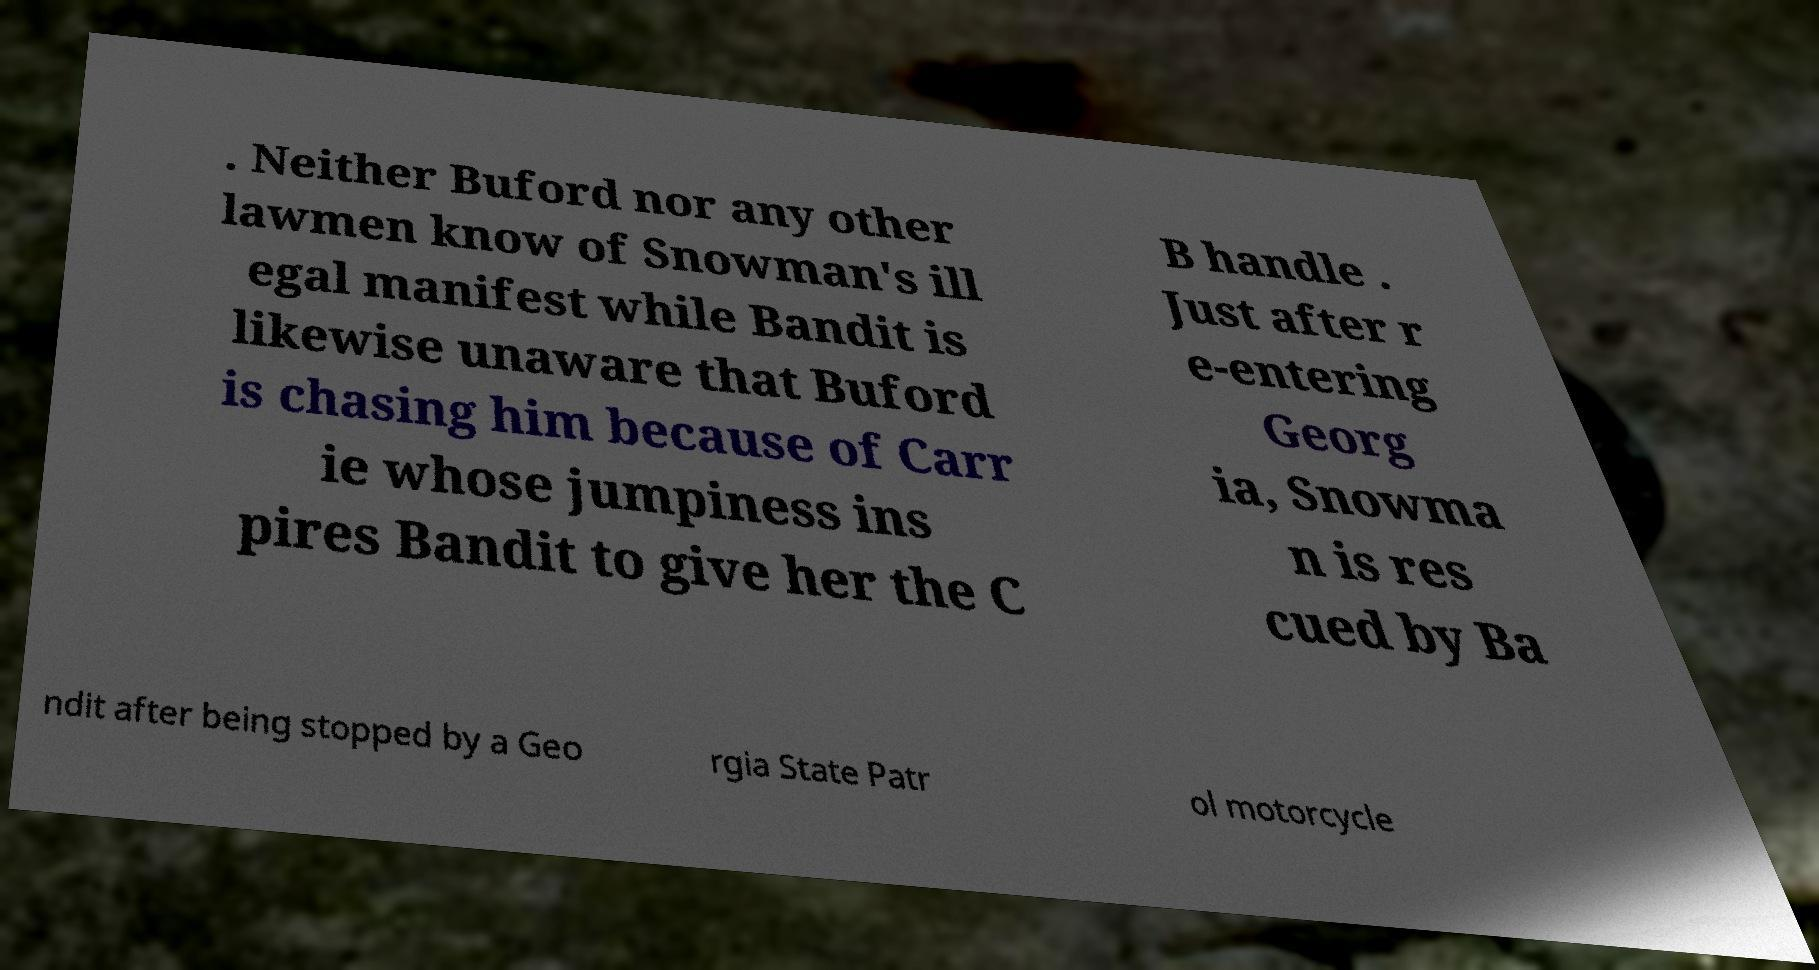Can you read and provide the text displayed in the image?This photo seems to have some interesting text. Can you extract and type it out for me? . Neither Buford nor any other lawmen know of Snowman's ill egal manifest while Bandit is likewise unaware that Buford is chasing him because of Carr ie whose jumpiness ins pires Bandit to give her the C B handle . Just after r e-entering Georg ia, Snowma n is res cued by Ba ndit after being stopped by a Geo rgia State Patr ol motorcycle 